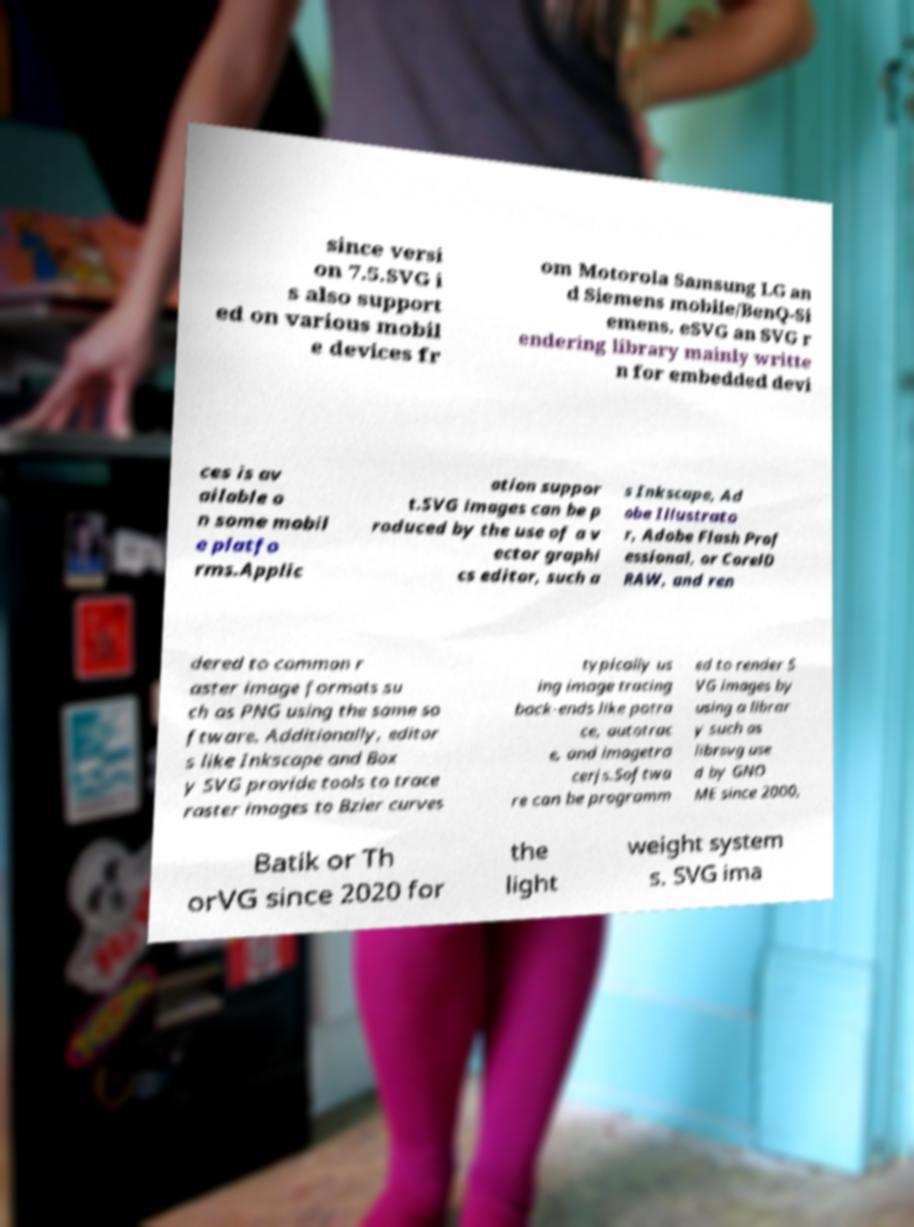For documentation purposes, I need the text within this image transcribed. Could you provide that? since versi on 7.5.SVG i s also support ed on various mobil e devices fr om Motorola Samsung LG an d Siemens mobile/BenQ-Si emens. eSVG an SVG r endering library mainly writte n for embedded devi ces is av ailable o n some mobil e platfo rms.Applic ation suppor t.SVG images can be p roduced by the use of a v ector graphi cs editor, such a s Inkscape, Ad obe Illustrato r, Adobe Flash Prof essional, or CorelD RAW, and ren dered to common r aster image formats su ch as PNG using the same so ftware. Additionally, editor s like Inkscape and Box y SVG provide tools to trace raster images to Bzier curves typically us ing image tracing back-ends like potra ce, autotrac e, and imagetra cerjs.Softwa re can be programm ed to render S VG images by using a librar y such as librsvg use d by GNO ME since 2000, Batik or Th orVG since 2020 for the light weight system s. SVG ima 